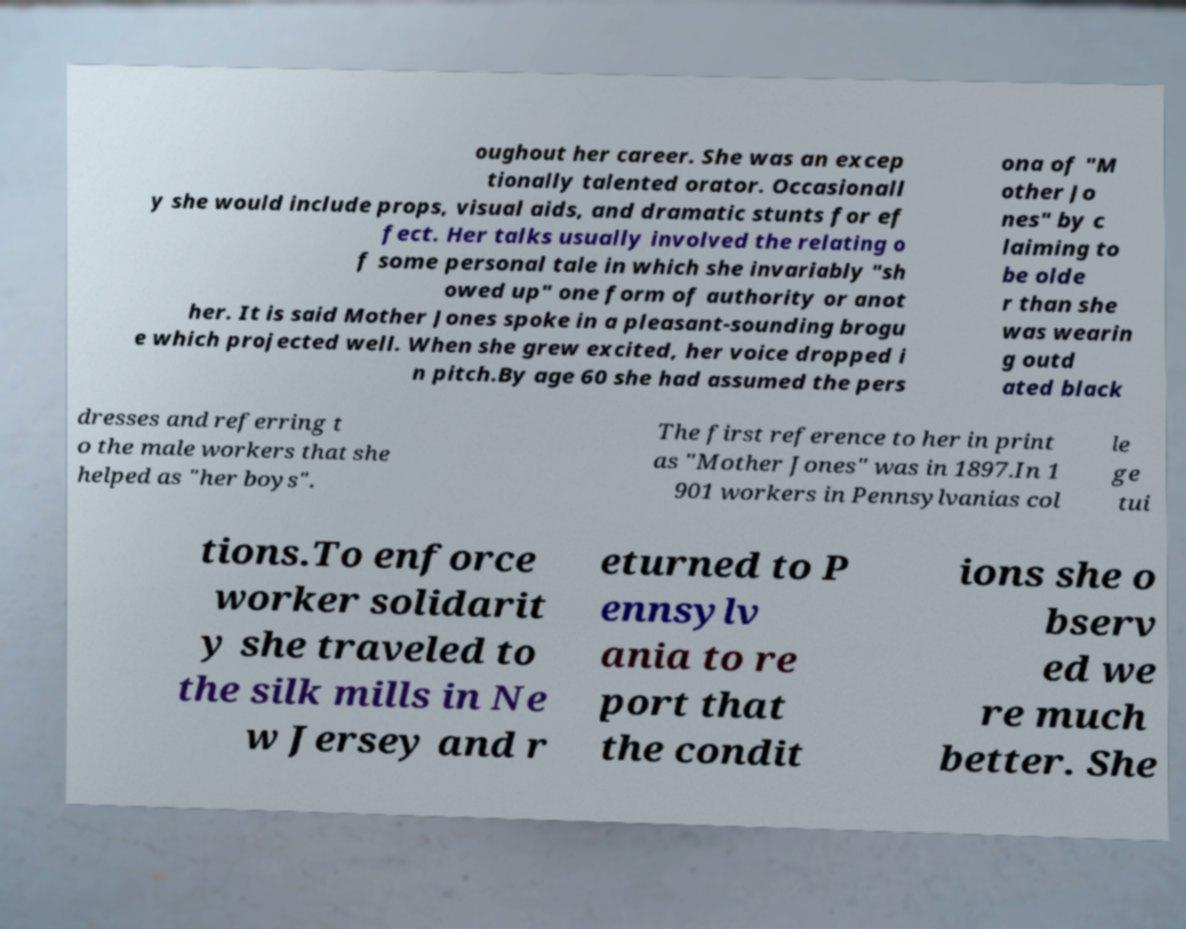There's text embedded in this image that I need extracted. Can you transcribe it verbatim? oughout her career. She was an excep tionally talented orator. Occasionall y she would include props, visual aids, and dramatic stunts for ef fect. Her talks usually involved the relating o f some personal tale in which she invariably "sh owed up" one form of authority or anot her. It is said Mother Jones spoke in a pleasant-sounding brogu e which projected well. When she grew excited, her voice dropped i n pitch.By age 60 she had assumed the pers ona of "M other Jo nes" by c laiming to be olde r than she was wearin g outd ated black dresses and referring t o the male workers that she helped as "her boys". The first reference to her in print as "Mother Jones" was in 1897.In 1 901 workers in Pennsylvanias col le ge tui tions.To enforce worker solidarit y she traveled to the silk mills in Ne w Jersey and r eturned to P ennsylv ania to re port that the condit ions she o bserv ed we re much better. She 